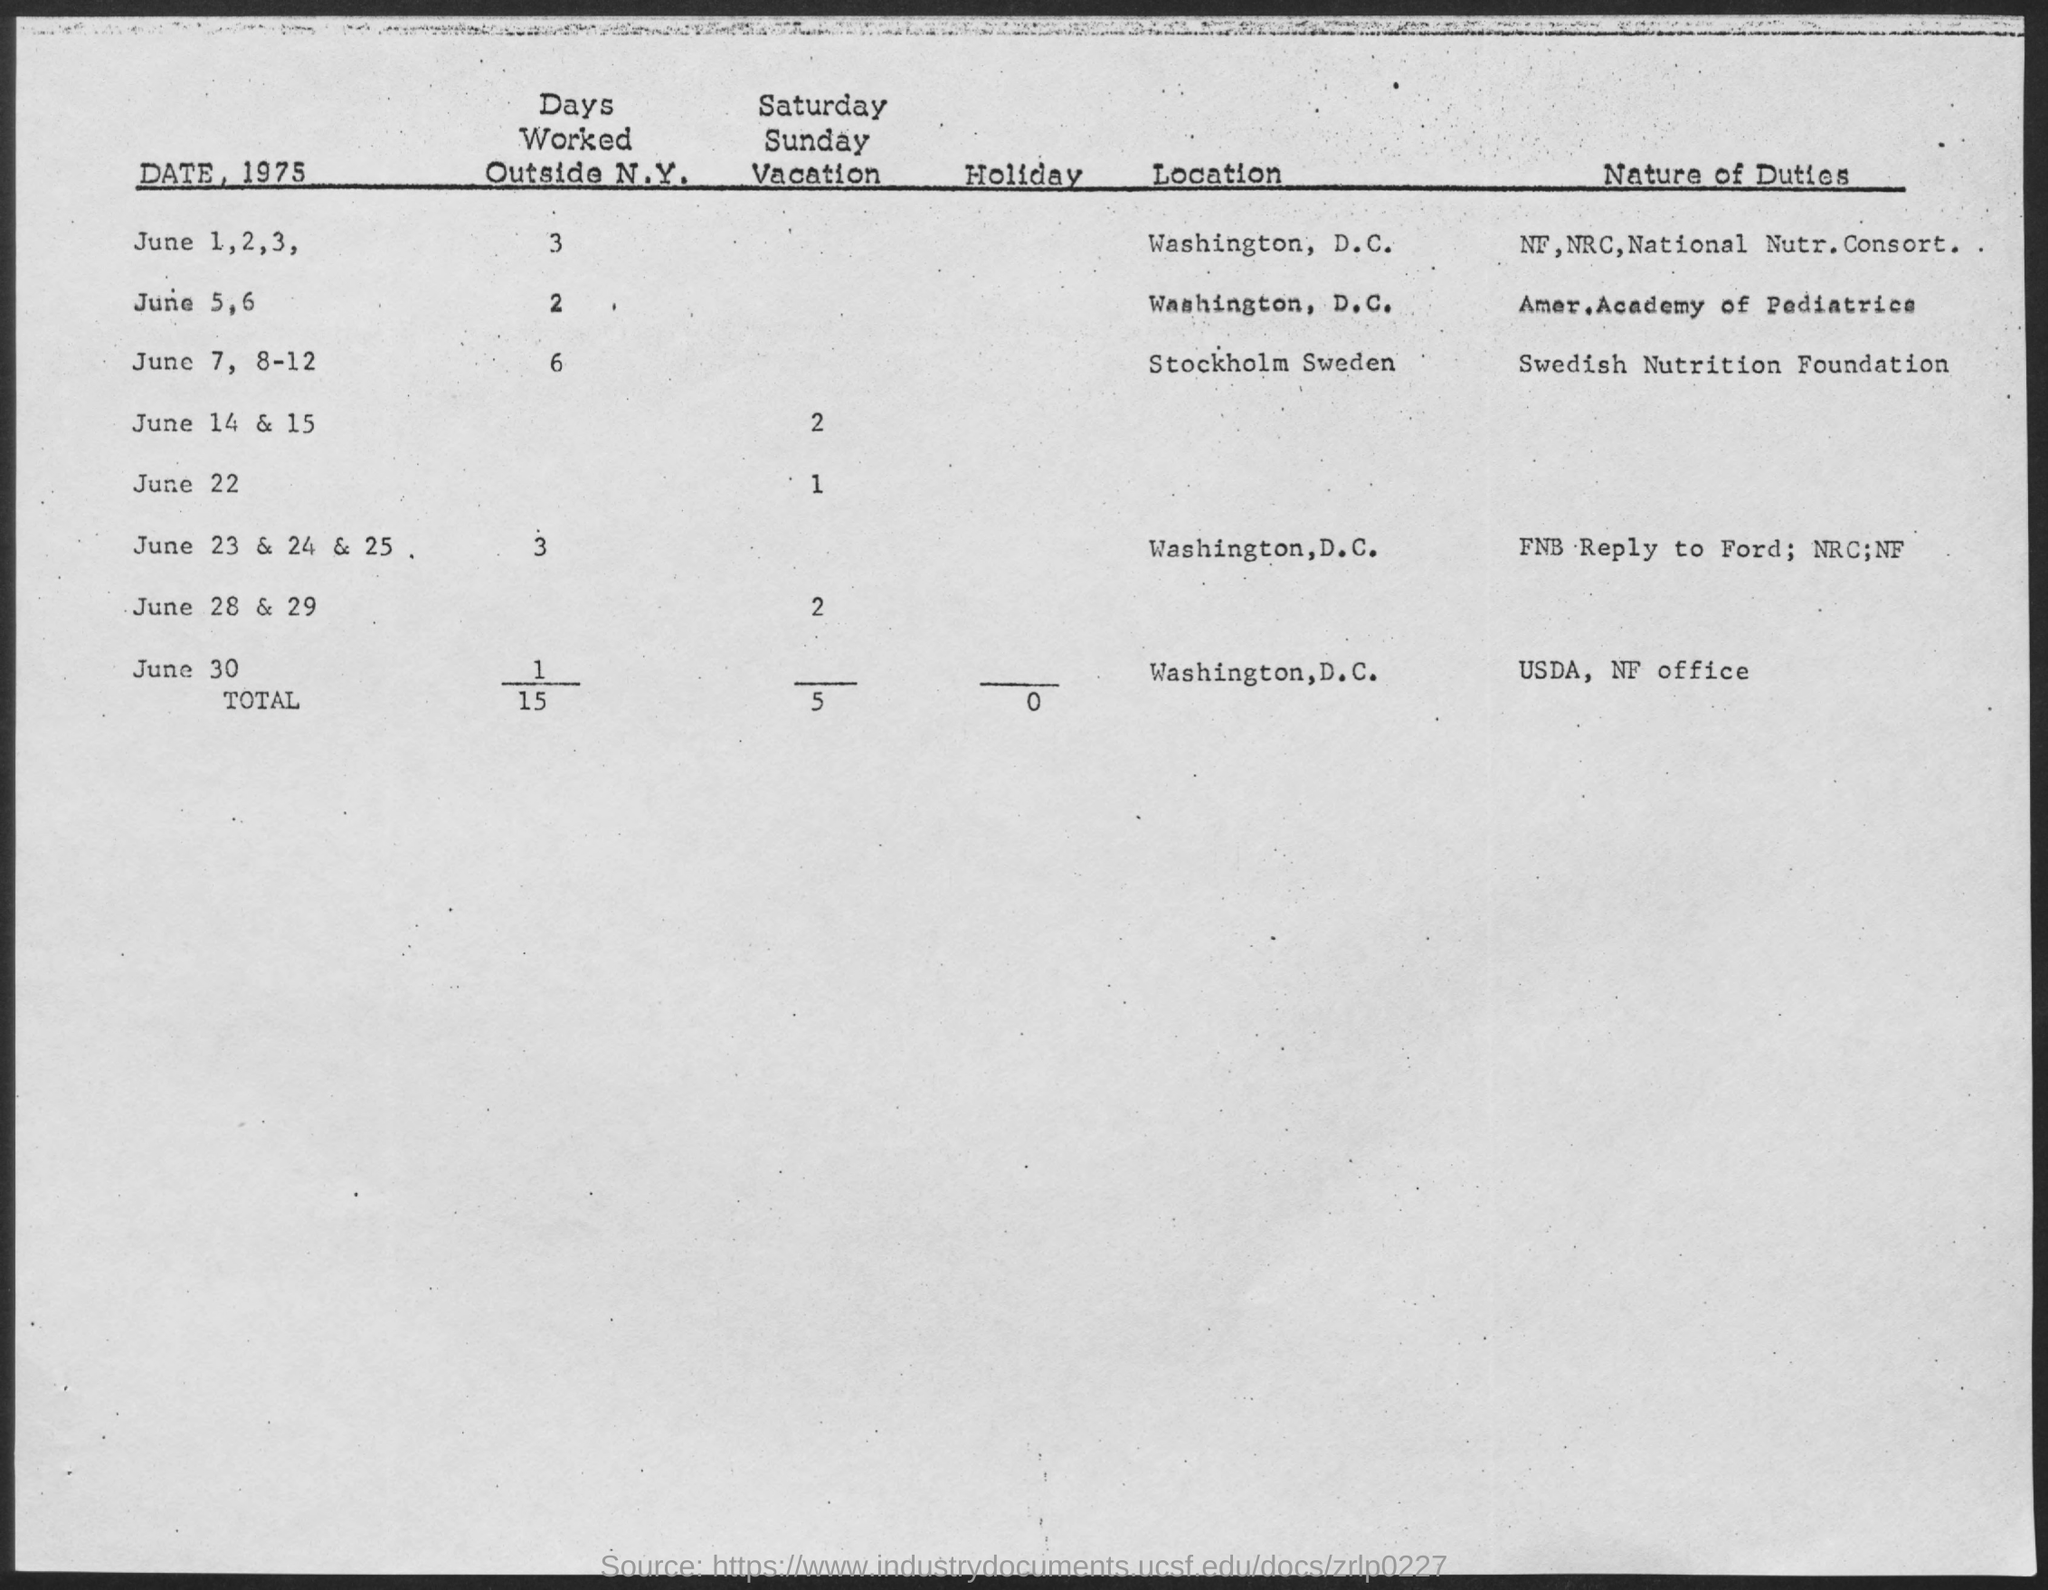Mention a couple of crucial points in this snapshot. On June 5 and 6, the American Academy of Pediatrics will be discussing the nature of duty. The total number of holidays is unspecified and ranges from 0 to... What is the nature of duty on June 7, 8-12, according to the Swedish Nutrition Foundation? On June 7, 8, 9, and 10, the location is Stockholm, Sweden. On June 7, 8-12, the location of Stockholm, Sweden will be. 